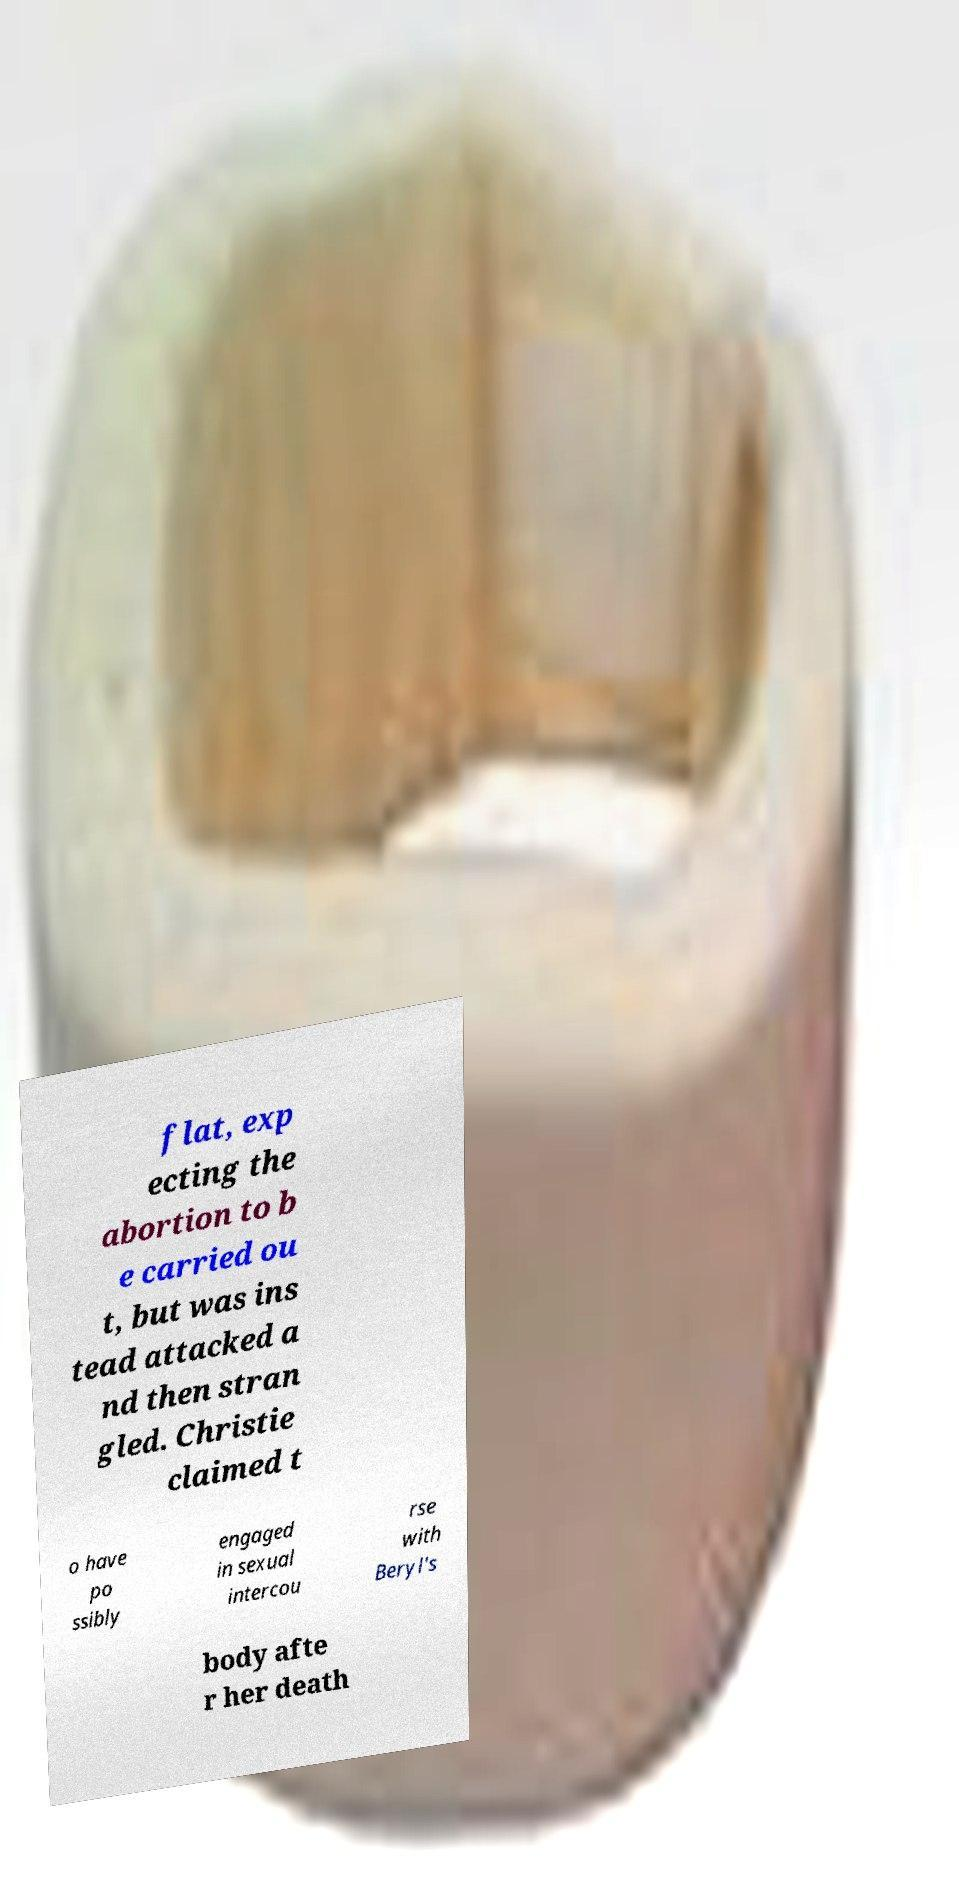What messages or text are displayed in this image? I need them in a readable, typed format. flat, exp ecting the abortion to b e carried ou t, but was ins tead attacked a nd then stran gled. Christie claimed t o have po ssibly engaged in sexual intercou rse with Beryl's body afte r her death 